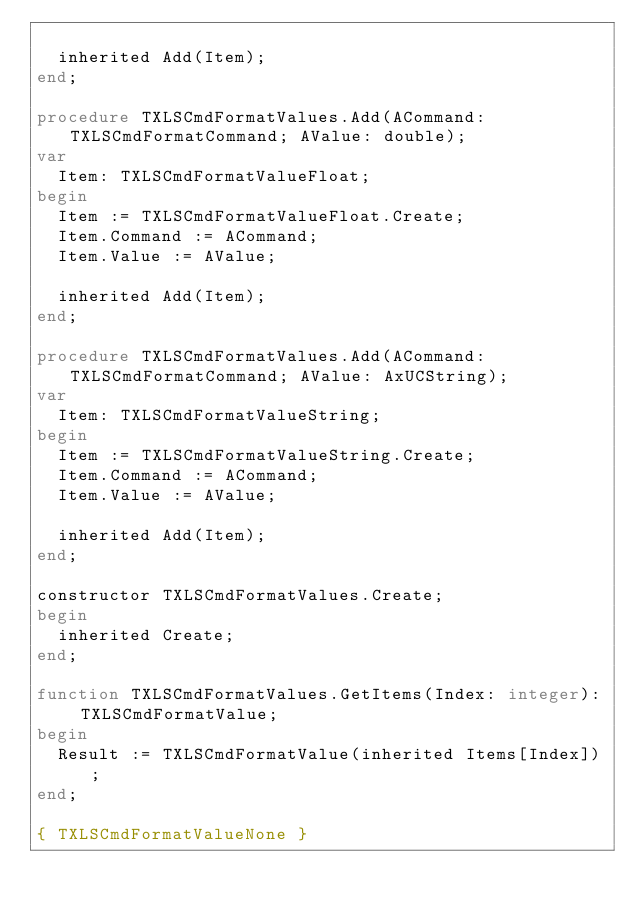Convert code to text. <code><loc_0><loc_0><loc_500><loc_500><_Pascal_>
  inherited Add(Item);
end;

procedure TXLSCmdFormatValues.Add(ACommand: TXLSCmdFormatCommand; AValue: double);
var
  Item: TXLSCmdFormatValueFloat;
begin
  Item := TXLSCmdFormatValueFloat.Create;
  Item.Command := ACommand;
  Item.Value := AValue;

  inherited Add(Item);
end;

procedure TXLSCmdFormatValues.Add(ACommand: TXLSCmdFormatCommand; AValue: AxUCString);
var
  Item: TXLSCmdFormatValueString;
begin
  Item := TXLSCmdFormatValueString.Create;
  Item.Command := ACommand;
  Item.Value := AValue;

  inherited Add(Item);
end;

constructor TXLSCmdFormatValues.Create;
begin
  inherited Create;
end;

function TXLSCmdFormatValues.GetItems(Index: integer): TXLSCmdFormatValue;
begin
  Result := TXLSCmdFormatValue(inherited Items[Index]);
end;

{ TXLSCmdFormatValueNone }
</code> 